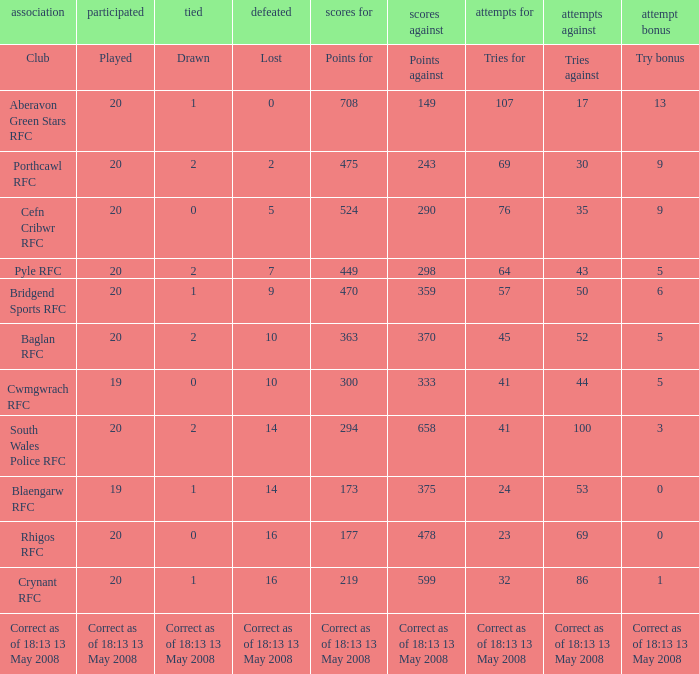What is the tries for when 52 was the tries against? 45.0. 